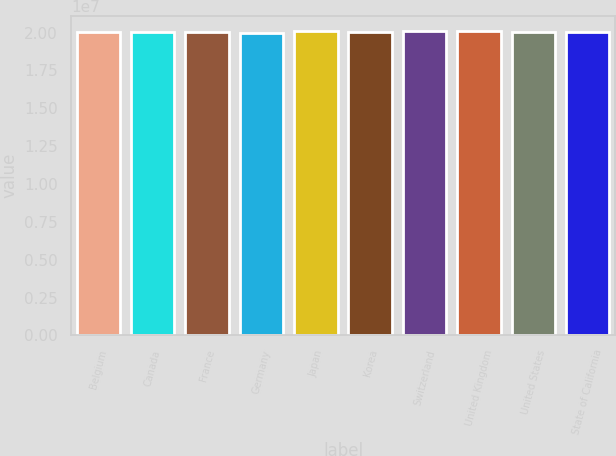<chart> <loc_0><loc_0><loc_500><loc_500><bar_chart><fcel>Belgium<fcel>Canada<fcel>France<fcel>Germany<fcel>Japan<fcel>Korea<fcel>Switzerland<fcel>United Kingdom<fcel>United States<fcel>State of California<nl><fcel>2.0057e+07<fcel>2.0012e+07<fcel>2.0066e+07<fcel>1.9992e+07<fcel>2.0075e+07<fcel>2.0048e+07<fcel>2.0084e+07<fcel>2.0102e+07<fcel>2.003e+07<fcel>2.0039e+07<nl></chart> 